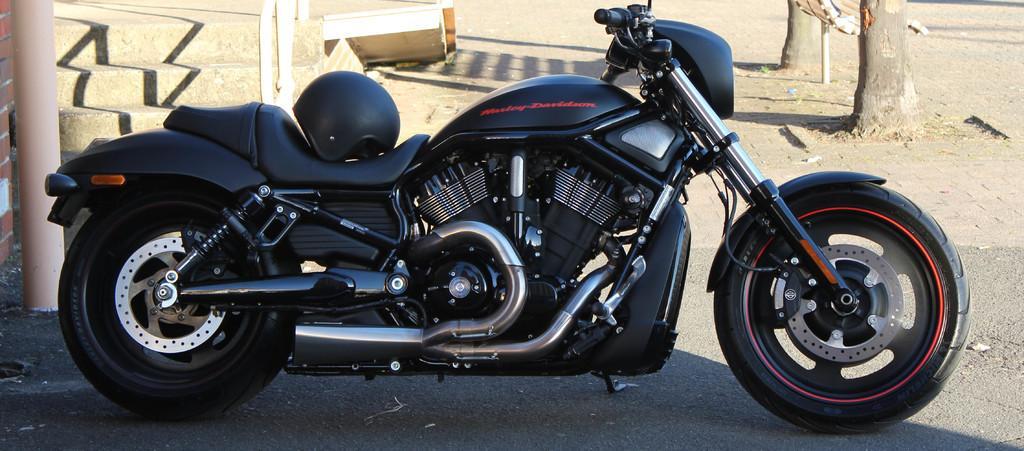Can you describe this image briefly? In this image in front there is a bike on the road. On the bike there is a helmet. Behind the bike there are stairs. There is a pillar. On the right side of the image there are two trees. 